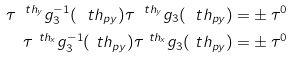Convert formula to latex. <formula><loc_0><loc_0><loc_500><loc_500>\tau ^ { \ t h _ { y } } g _ { 3 } ^ { - 1 } ( \ t h _ { p y } ) \tau ^ { \ t h _ { y } } g _ { 3 } ( \ t h _ { p y } ) = & \pm \tau ^ { 0 } \\ \tau ^ { \ t h _ { x } } g _ { 3 } ^ { - 1 } ( \ t h _ { p y } ) \tau ^ { \ t h _ { x } } g _ { 3 } ( \ t h _ { p y } ) = & \pm \tau ^ { 0 }</formula> 